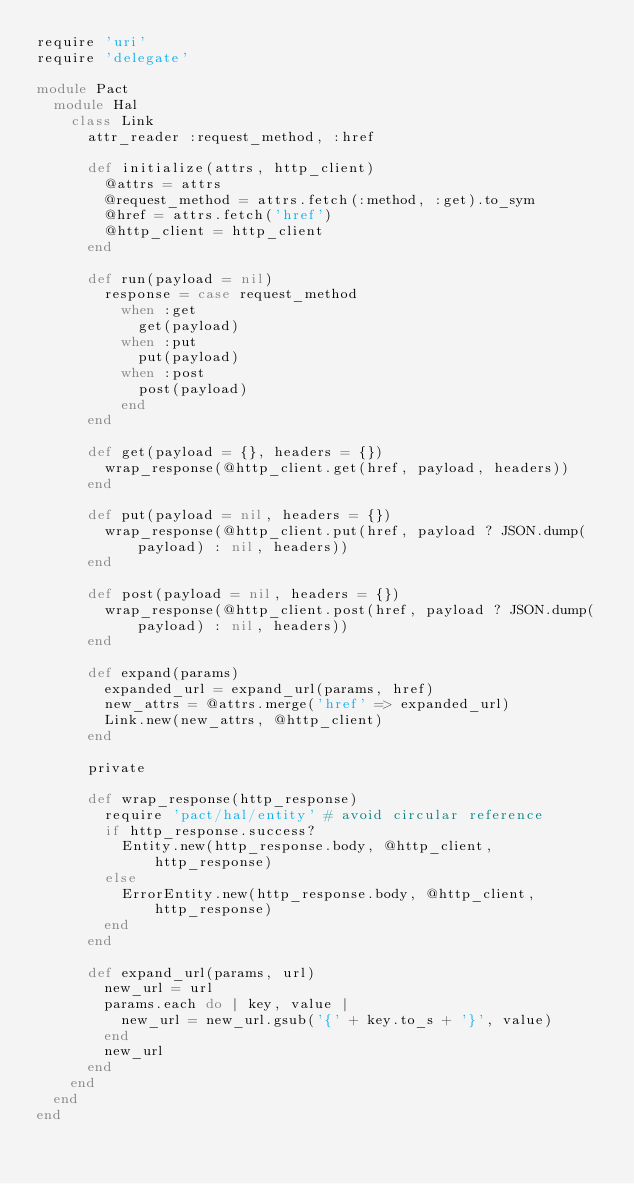<code> <loc_0><loc_0><loc_500><loc_500><_Ruby_>require 'uri'
require 'delegate'

module Pact
  module Hal
    class Link
      attr_reader :request_method, :href

      def initialize(attrs, http_client)
        @attrs = attrs
        @request_method = attrs.fetch(:method, :get).to_sym
        @href = attrs.fetch('href')
        @http_client = http_client
      end

      def run(payload = nil)
        response = case request_method
          when :get
            get(payload)
          when :put
            put(payload)
          when :post
            post(payload)
          end
      end

      def get(payload = {}, headers = {})
        wrap_response(@http_client.get(href, payload, headers))
      end

      def put(payload = nil, headers = {})
        wrap_response(@http_client.put(href, payload ? JSON.dump(payload) : nil, headers))
      end

      def post(payload = nil, headers = {})
        wrap_response(@http_client.post(href, payload ? JSON.dump(payload) : nil, headers))
      end

      def expand(params)
        expanded_url = expand_url(params, href)
        new_attrs = @attrs.merge('href' => expanded_url)
        Link.new(new_attrs, @http_client)
      end

      private

      def wrap_response(http_response)
        require 'pact/hal/entity' # avoid circular reference
        if http_response.success?
          Entity.new(http_response.body, @http_client, http_response)
        else
          ErrorEntity.new(http_response.body, @http_client, http_response)
        end
      end

      def expand_url(params, url)
        new_url = url
        params.each do | key, value |
          new_url = new_url.gsub('{' + key.to_s + '}', value)
        end
        new_url
      end
    end
  end
end
</code> 